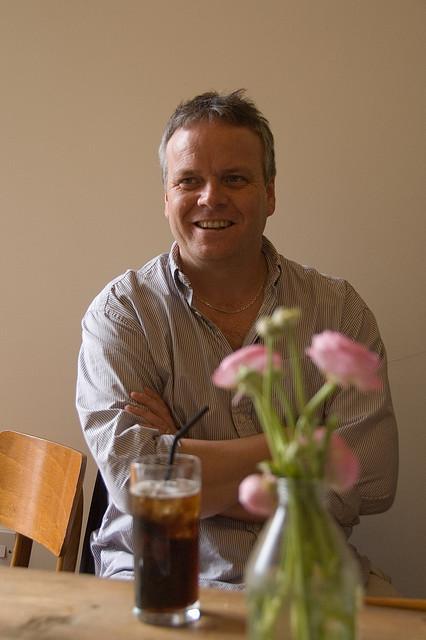Is the man in the picture wearing an apron?
Concise answer only. No. Is the man sad?
Write a very short answer. No. Is the man drinking coke?
Give a very brief answer. Yes. Is the man smiling?
Be succinct. Yes. 